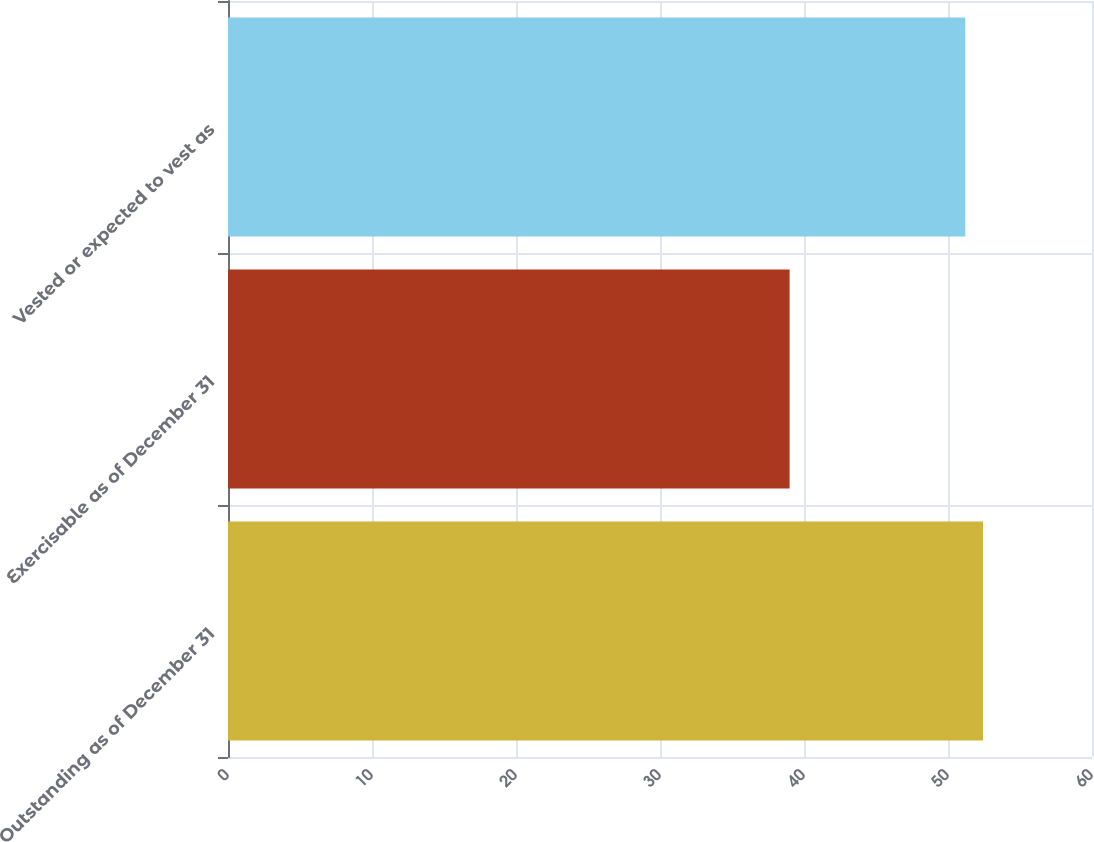Convert chart to OTSL. <chart><loc_0><loc_0><loc_500><loc_500><bar_chart><fcel>Outstanding as of December 31<fcel>Exercisable as of December 31<fcel>Vested or expected to vest as<nl><fcel>52.43<fcel>39<fcel>51.2<nl></chart> 